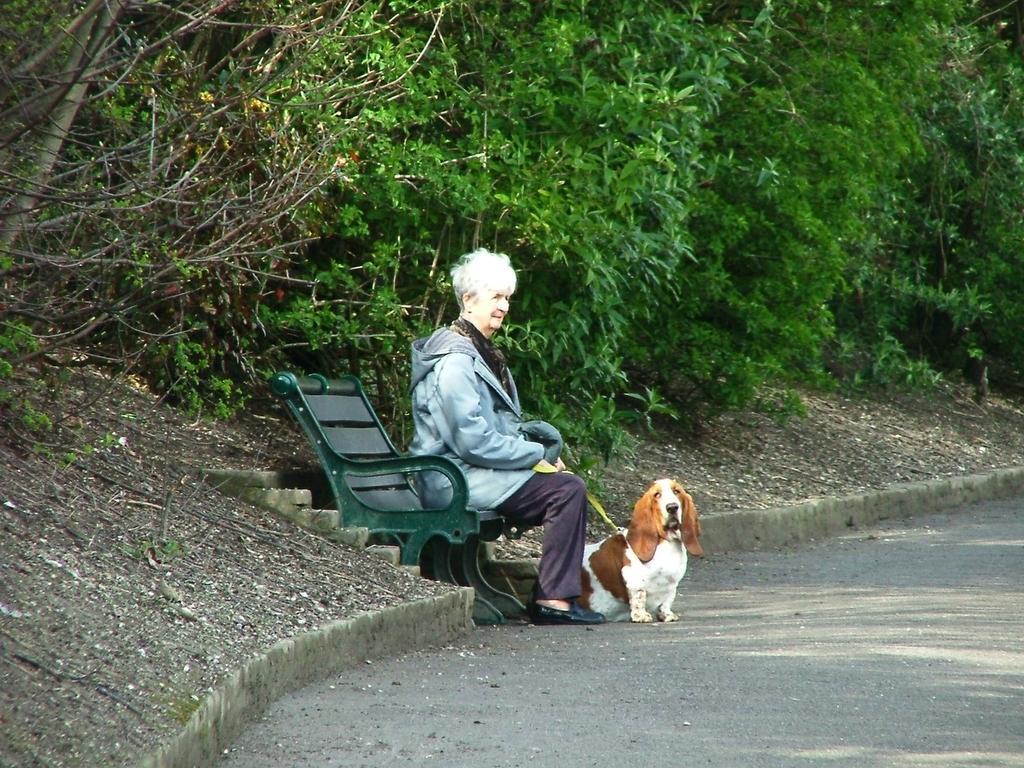Can you describe this image briefly? This image consists of trees on the top and there is a bench in the middle, on which lady is sitting. She is holding a dog in her hand. She is wearing sweater. 